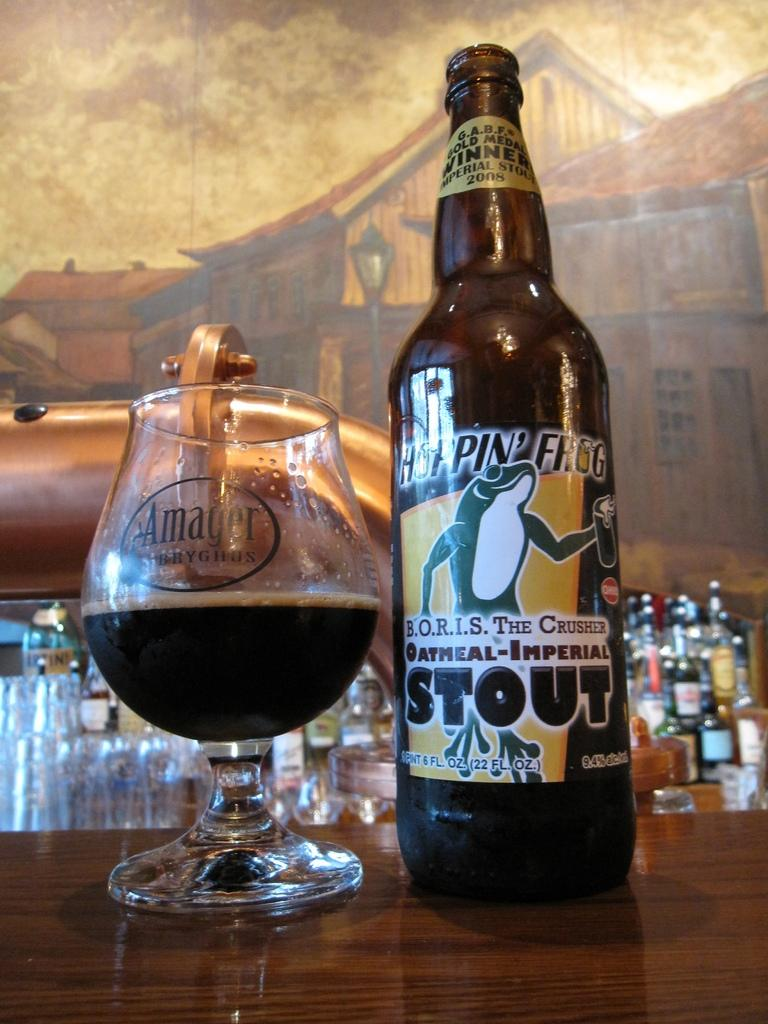<image>
Relay a brief, clear account of the picture shown. Bottle of Oatmeal-Imperial Stout on the bar next to a wine glass half full. 